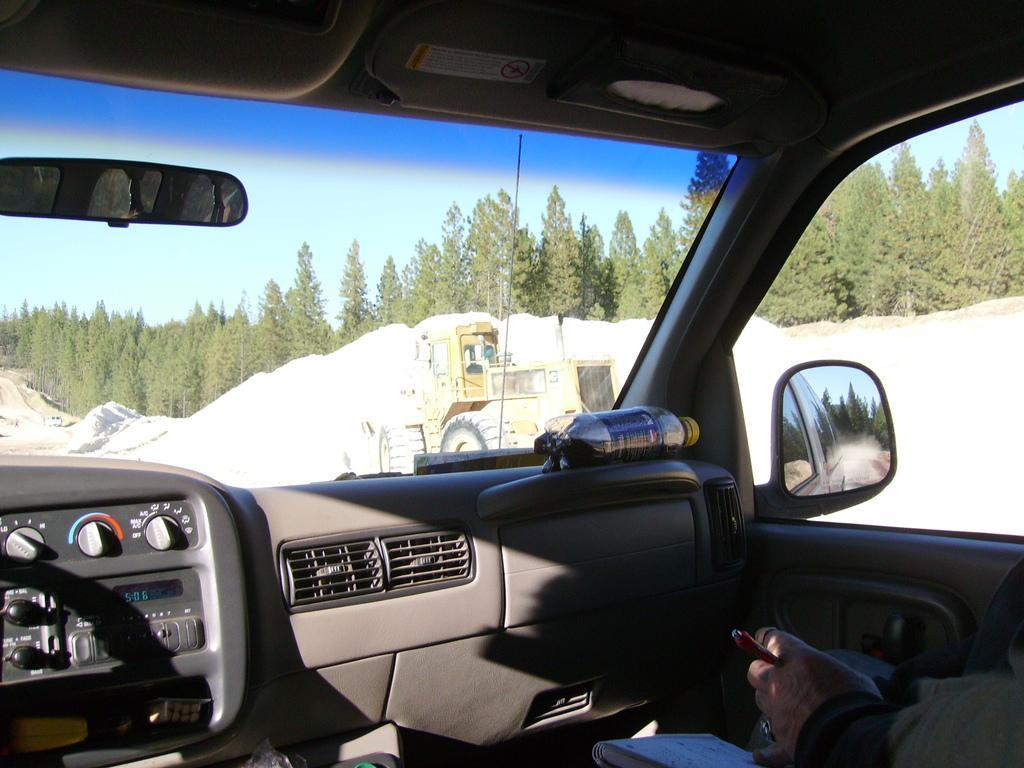In one or two sentences, can you explain what this image depicts? This is an inside view of a car where we can see a person, book, bottle, mirrors and glasses. Behind the glass, we can see a vehicle, land, trees and the sky. 